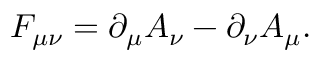Convert formula to latex. <formula><loc_0><loc_0><loc_500><loc_500>F _ { \mu \nu } = \partial _ { \mu } A _ { \nu } - \partial _ { \nu } A _ { \mu } .</formula> 